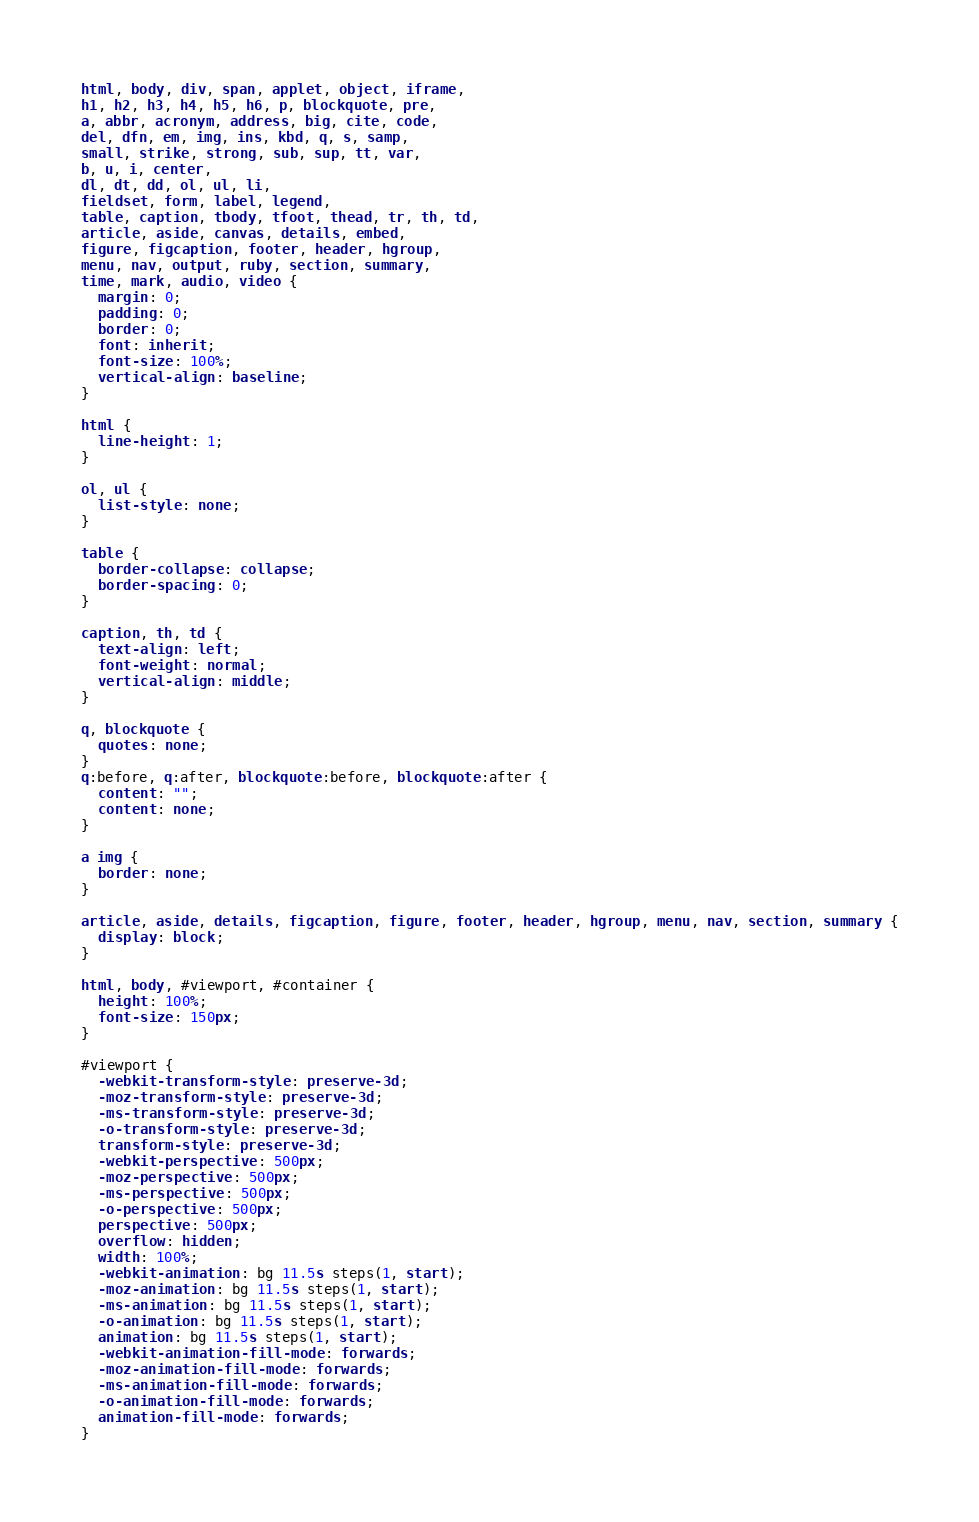Convert code to text. <code><loc_0><loc_0><loc_500><loc_500><_CSS_>html, body, div, span, applet, object, iframe,
h1, h2, h3, h4, h5, h6, p, blockquote, pre,
a, abbr, acronym, address, big, cite, code,
del, dfn, em, img, ins, kbd, q, s, samp,
small, strike, strong, sub, sup, tt, var,
b, u, i, center,
dl, dt, dd, ol, ul, li,
fieldset, form, label, legend,
table, caption, tbody, tfoot, thead, tr, th, td,
article, aside, canvas, details, embed,
figure, figcaption, footer, header, hgroup,
menu, nav, output, ruby, section, summary,
time, mark, audio, video {
  margin: 0;
  padding: 0;
  border: 0;
  font: inherit;
  font-size: 100%;
  vertical-align: baseline;
}

html {
  line-height: 1;
}

ol, ul {
  list-style: none;
}

table {
  border-collapse: collapse;
  border-spacing: 0;
}

caption, th, td {
  text-align: left;
  font-weight: normal;
  vertical-align: middle;
}

q, blockquote {
  quotes: none;
}
q:before, q:after, blockquote:before, blockquote:after {
  content: "";
  content: none;
}

a img {
  border: none;
}

article, aside, details, figcaption, figure, footer, header, hgroup, menu, nav, section, summary {
  display: block;
}

html, body, #viewport, #container {
  height: 100%;
  font-size: 150px;
}

#viewport {
  -webkit-transform-style: preserve-3d;
  -moz-transform-style: preserve-3d;
  -ms-transform-style: preserve-3d;
  -o-transform-style: preserve-3d;
  transform-style: preserve-3d;
  -webkit-perspective: 500px;
  -moz-perspective: 500px;
  -ms-perspective: 500px;
  -o-perspective: 500px;
  perspective: 500px;
  overflow: hidden;
  width: 100%;
  -webkit-animation: bg 11.5s steps(1, start);
  -moz-animation: bg 11.5s steps(1, start);
  -ms-animation: bg 11.5s steps(1, start);
  -o-animation: bg 11.5s steps(1, start);
  animation: bg 11.5s steps(1, start);
  -webkit-animation-fill-mode: forwards;
  -moz-animation-fill-mode: forwards;
  -ms-animation-fill-mode: forwards;
  -o-animation-fill-mode: forwards;
  animation-fill-mode: forwards;
}
</code> 